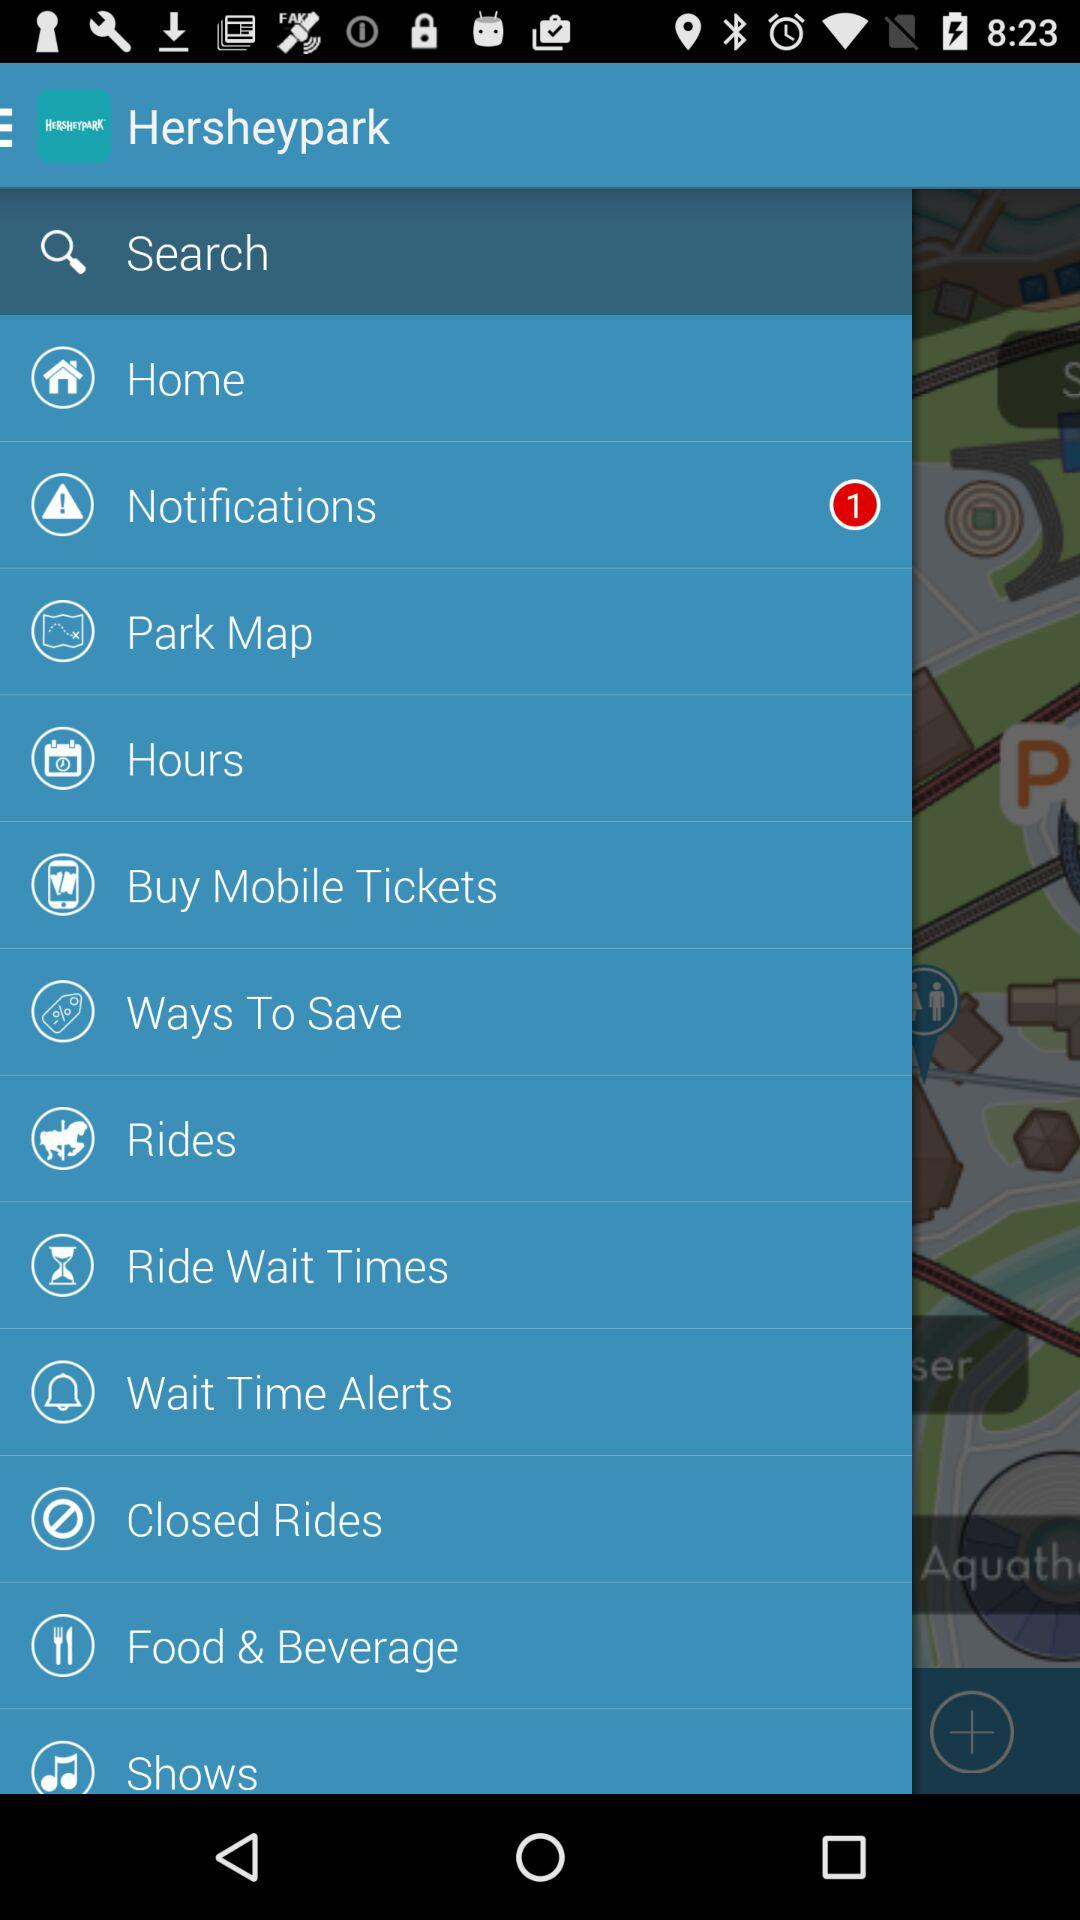How much is a mobile ticket?
When the provided information is insufficient, respond with <no answer>. <no answer> 